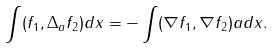<formula> <loc_0><loc_0><loc_500><loc_500>\int ( f _ { 1 } , \Delta _ { a } f _ { 2 } ) d x = - \int ( \nabla f _ { 1 } , \nabla f _ { 2 } ) a d x .</formula> 